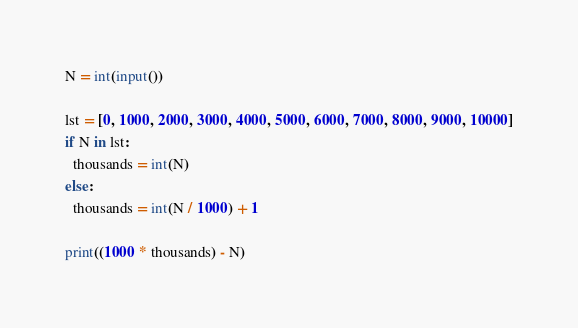<code> <loc_0><loc_0><loc_500><loc_500><_Python_>N = int(input())

lst = [0, 1000, 2000, 3000, 4000, 5000, 6000, 7000, 8000, 9000, 10000]
if N in lst:
  thousands = int(N)
else:
  thousands = int(N / 1000) + 1
 
print((1000 * thousands) - N)</code> 